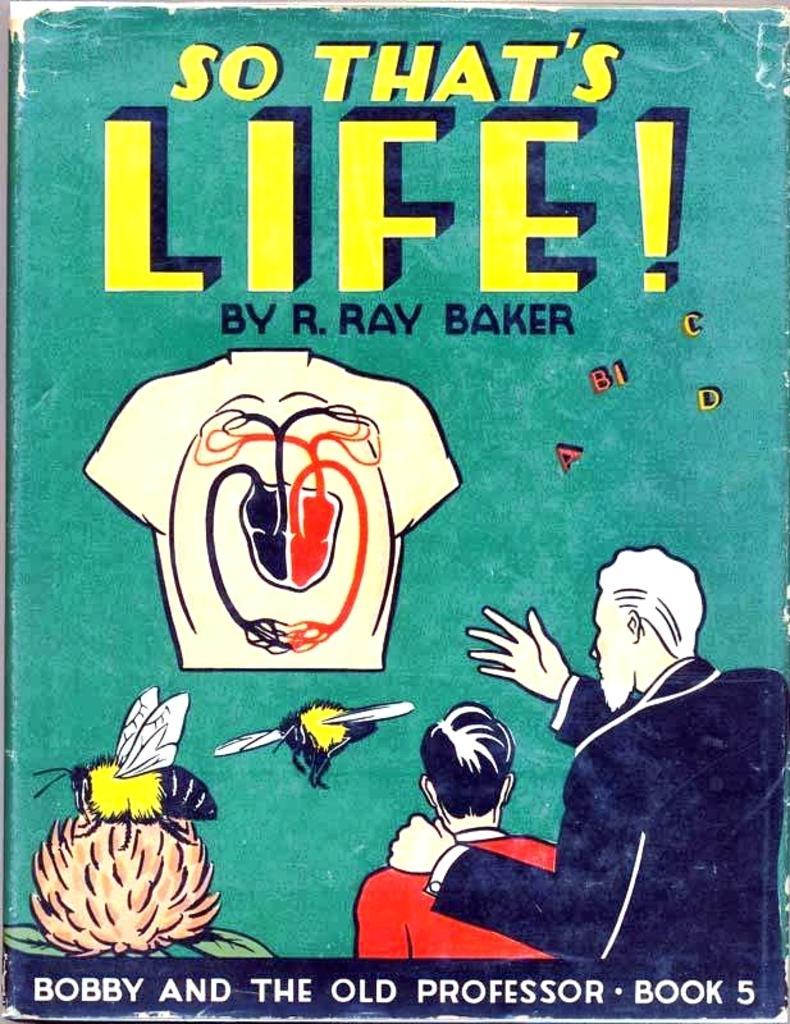Can you describe this image briefly? In the image there is a poster with green background. At the bottom right corner of the image there are two men. And at the bottom left corner of the image there is a flower with bees. And in the middle of the poster there is a shirt image. At the top of the poster there is something written on it. 